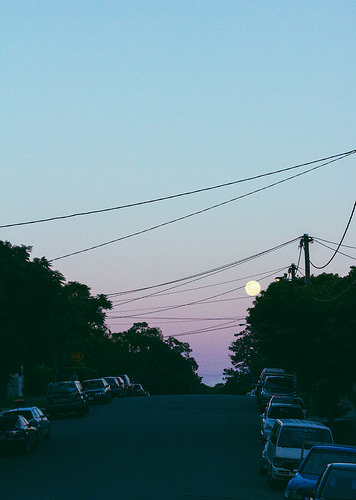<image>
Can you confirm if the car is on the road? Yes. Looking at the image, I can see the car is positioned on top of the road, with the road providing support. 